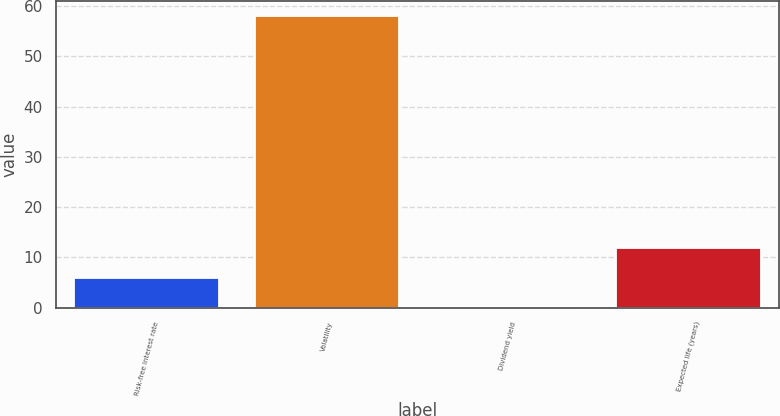<chart> <loc_0><loc_0><loc_500><loc_500><bar_chart><fcel>Risk-free interest rate<fcel>Volatility<fcel>Dividend yield<fcel>Expected life (years)<nl><fcel>5.98<fcel>58<fcel>0.2<fcel>11.76<nl></chart> 